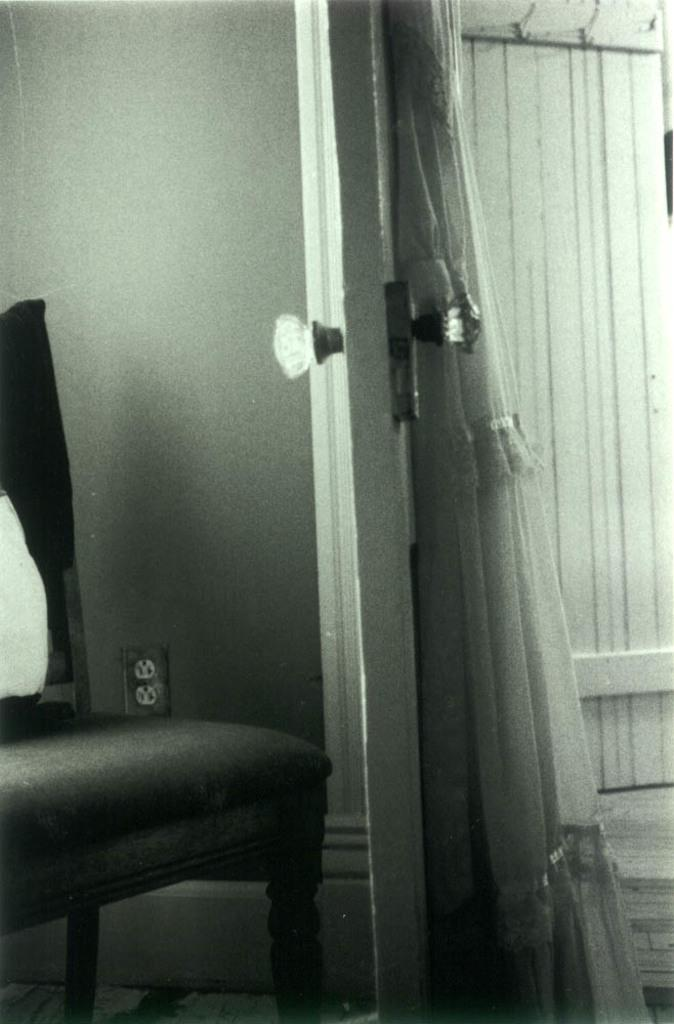What type of furniture is present in the image? There is a chair in the image. What can be used to enter or exit a room in the image? There is a door in the image. What is visible in the background of the image? There is a wall and a curtain in the background of the image. What type of advice is being given in the image? There is no indication of any advice being given in the image. Is anyone wearing a mask in the image? There is no mention of a mask or any person wearing one in the image. 